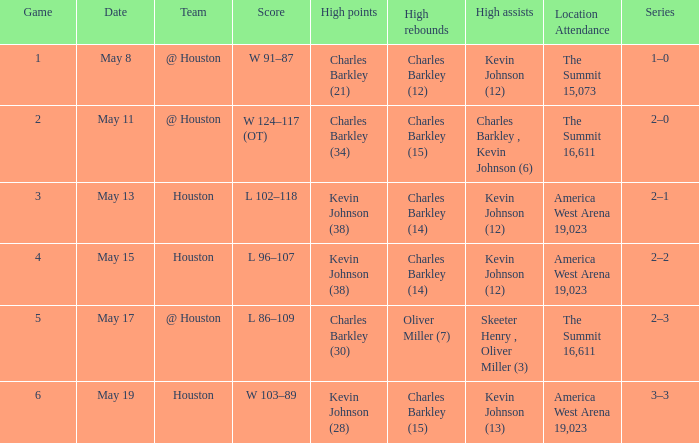In how many different games did Oliver Miller (7) did the high rebounds? 1.0. 